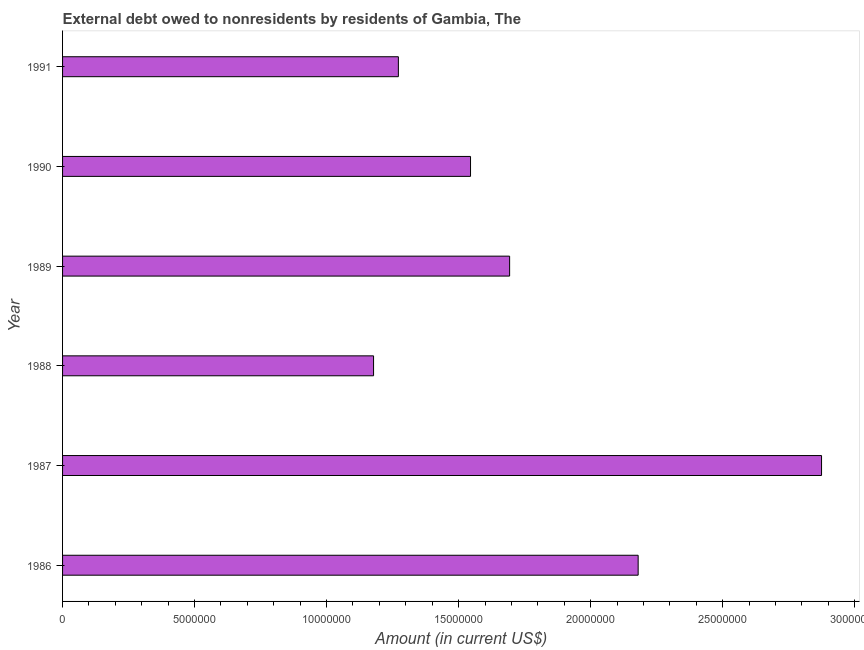Does the graph contain any zero values?
Your response must be concise. No. What is the title of the graph?
Keep it short and to the point. External debt owed to nonresidents by residents of Gambia, The. What is the label or title of the X-axis?
Your answer should be very brief. Amount (in current US$). What is the debt in 1990?
Make the answer very short. 1.55e+07. Across all years, what is the maximum debt?
Offer a very short reply. 2.87e+07. Across all years, what is the minimum debt?
Offer a very short reply. 1.18e+07. What is the sum of the debt?
Your answer should be very brief. 1.07e+08. What is the difference between the debt in 1986 and 1991?
Offer a terse response. 9.08e+06. What is the average debt per year?
Offer a very short reply. 1.79e+07. What is the median debt?
Offer a terse response. 1.62e+07. What is the ratio of the debt in 1987 to that in 1989?
Provide a short and direct response. 1.7. Is the difference between the debt in 1986 and 1989 greater than the difference between any two years?
Provide a short and direct response. No. What is the difference between the highest and the second highest debt?
Offer a terse response. 6.95e+06. Is the sum of the debt in 1989 and 1990 greater than the maximum debt across all years?
Offer a terse response. Yes. What is the difference between the highest and the lowest debt?
Your response must be concise. 1.70e+07. Are all the bars in the graph horizontal?
Provide a short and direct response. Yes. Are the values on the major ticks of X-axis written in scientific E-notation?
Offer a very short reply. No. What is the Amount (in current US$) in 1986?
Make the answer very short. 2.18e+07. What is the Amount (in current US$) in 1987?
Your answer should be compact. 2.87e+07. What is the Amount (in current US$) of 1988?
Your response must be concise. 1.18e+07. What is the Amount (in current US$) in 1989?
Make the answer very short. 1.69e+07. What is the Amount (in current US$) in 1990?
Provide a succinct answer. 1.55e+07. What is the Amount (in current US$) in 1991?
Provide a succinct answer. 1.27e+07. What is the difference between the Amount (in current US$) in 1986 and 1987?
Give a very brief answer. -6.95e+06. What is the difference between the Amount (in current US$) in 1986 and 1988?
Provide a succinct answer. 1.00e+07. What is the difference between the Amount (in current US$) in 1986 and 1989?
Keep it short and to the point. 4.87e+06. What is the difference between the Amount (in current US$) in 1986 and 1990?
Provide a short and direct response. 6.35e+06. What is the difference between the Amount (in current US$) in 1986 and 1991?
Your answer should be very brief. 9.08e+06. What is the difference between the Amount (in current US$) in 1987 and 1988?
Give a very brief answer. 1.70e+07. What is the difference between the Amount (in current US$) in 1987 and 1989?
Your answer should be very brief. 1.18e+07. What is the difference between the Amount (in current US$) in 1987 and 1990?
Give a very brief answer. 1.33e+07. What is the difference between the Amount (in current US$) in 1987 and 1991?
Ensure brevity in your answer.  1.60e+07. What is the difference between the Amount (in current US$) in 1988 and 1989?
Keep it short and to the point. -5.15e+06. What is the difference between the Amount (in current US$) in 1988 and 1990?
Provide a succinct answer. -3.67e+06. What is the difference between the Amount (in current US$) in 1988 and 1991?
Give a very brief answer. -9.40e+05. What is the difference between the Amount (in current US$) in 1989 and 1990?
Keep it short and to the point. 1.48e+06. What is the difference between the Amount (in current US$) in 1989 and 1991?
Your answer should be compact. 4.21e+06. What is the difference between the Amount (in current US$) in 1990 and 1991?
Ensure brevity in your answer.  2.73e+06. What is the ratio of the Amount (in current US$) in 1986 to that in 1987?
Ensure brevity in your answer.  0.76. What is the ratio of the Amount (in current US$) in 1986 to that in 1988?
Provide a short and direct response. 1.85. What is the ratio of the Amount (in current US$) in 1986 to that in 1989?
Your response must be concise. 1.29. What is the ratio of the Amount (in current US$) in 1986 to that in 1990?
Offer a terse response. 1.41. What is the ratio of the Amount (in current US$) in 1986 to that in 1991?
Your answer should be compact. 1.71. What is the ratio of the Amount (in current US$) in 1987 to that in 1988?
Provide a short and direct response. 2.44. What is the ratio of the Amount (in current US$) in 1987 to that in 1989?
Ensure brevity in your answer.  1.7. What is the ratio of the Amount (in current US$) in 1987 to that in 1990?
Offer a terse response. 1.86. What is the ratio of the Amount (in current US$) in 1987 to that in 1991?
Your response must be concise. 2.26. What is the ratio of the Amount (in current US$) in 1988 to that in 1989?
Offer a very short reply. 0.7. What is the ratio of the Amount (in current US$) in 1988 to that in 1990?
Make the answer very short. 0.76. What is the ratio of the Amount (in current US$) in 1988 to that in 1991?
Your answer should be compact. 0.93. What is the ratio of the Amount (in current US$) in 1989 to that in 1990?
Provide a short and direct response. 1.1. What is the ratio of the Amount (in current US$) in 1989 to that in 1991?
Ensure brevity in your answer.  1.33. What is the ratio of the Amount (in current US$) in 1990 to that in 1991?
Ensure brevity in your answer.  1.22. 